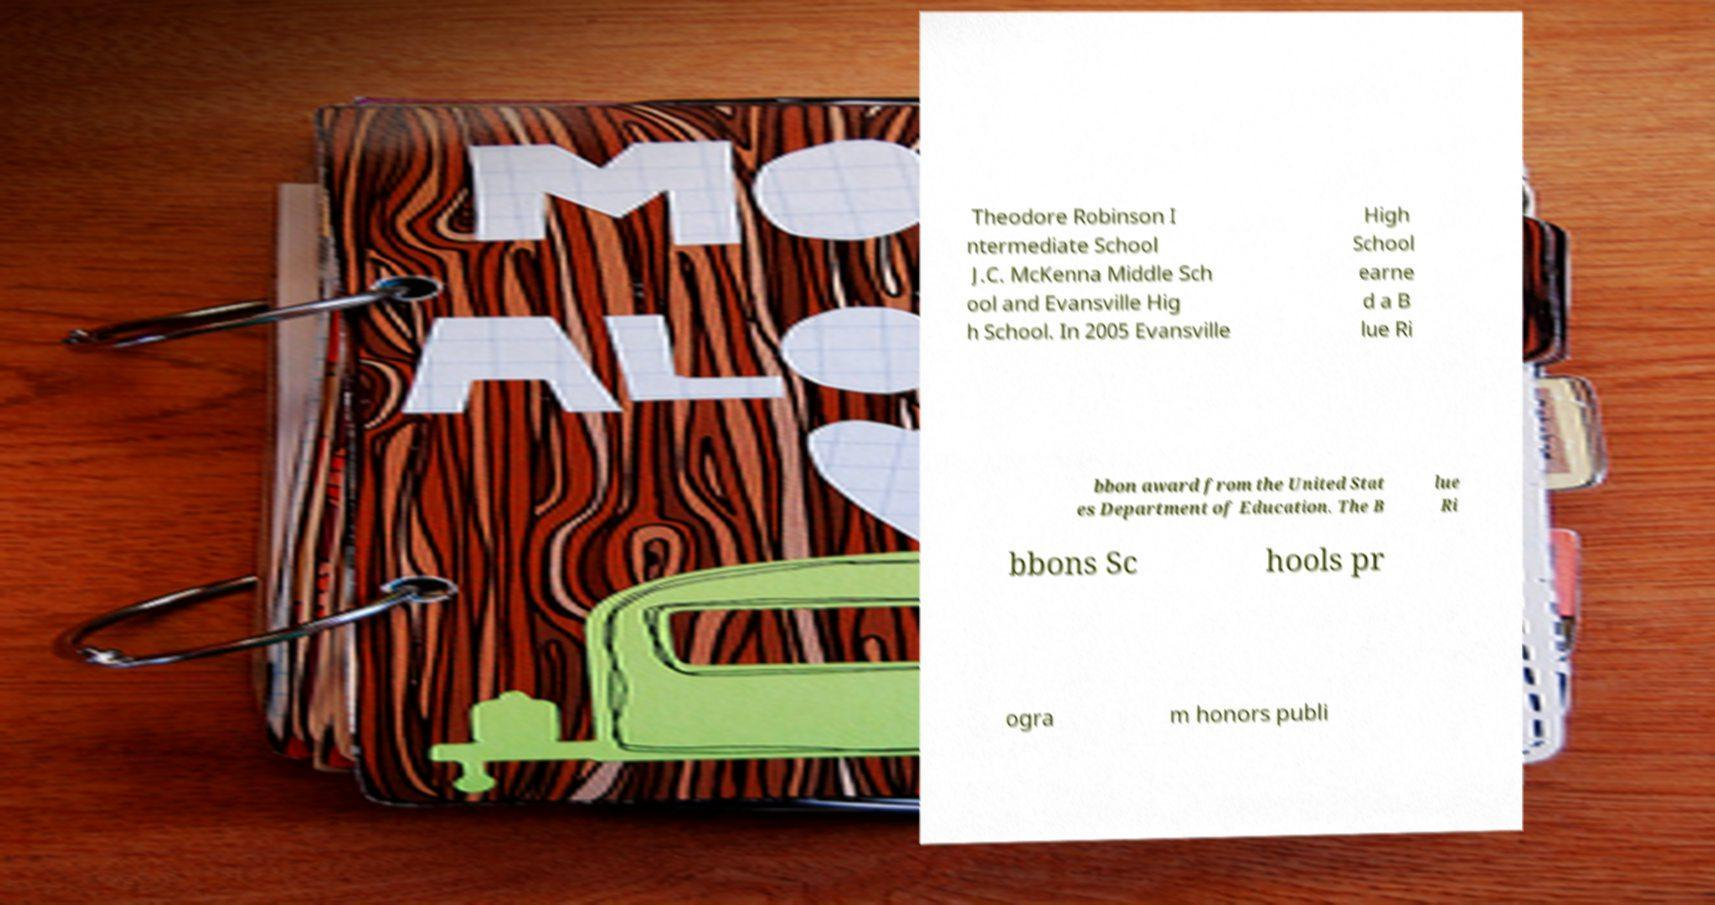Can you accurately transcribe the text from the provided image for me? Theodore Robinson I ntermediate School J.C. McKenna Middle Sch ool and Evansville Hig h School. In 2005 Evansville High School earne d a B lue Ri bbon award from the United Stat es Department of Education. The B lue Ri bbons Sc hools pr ogra m honors publi 